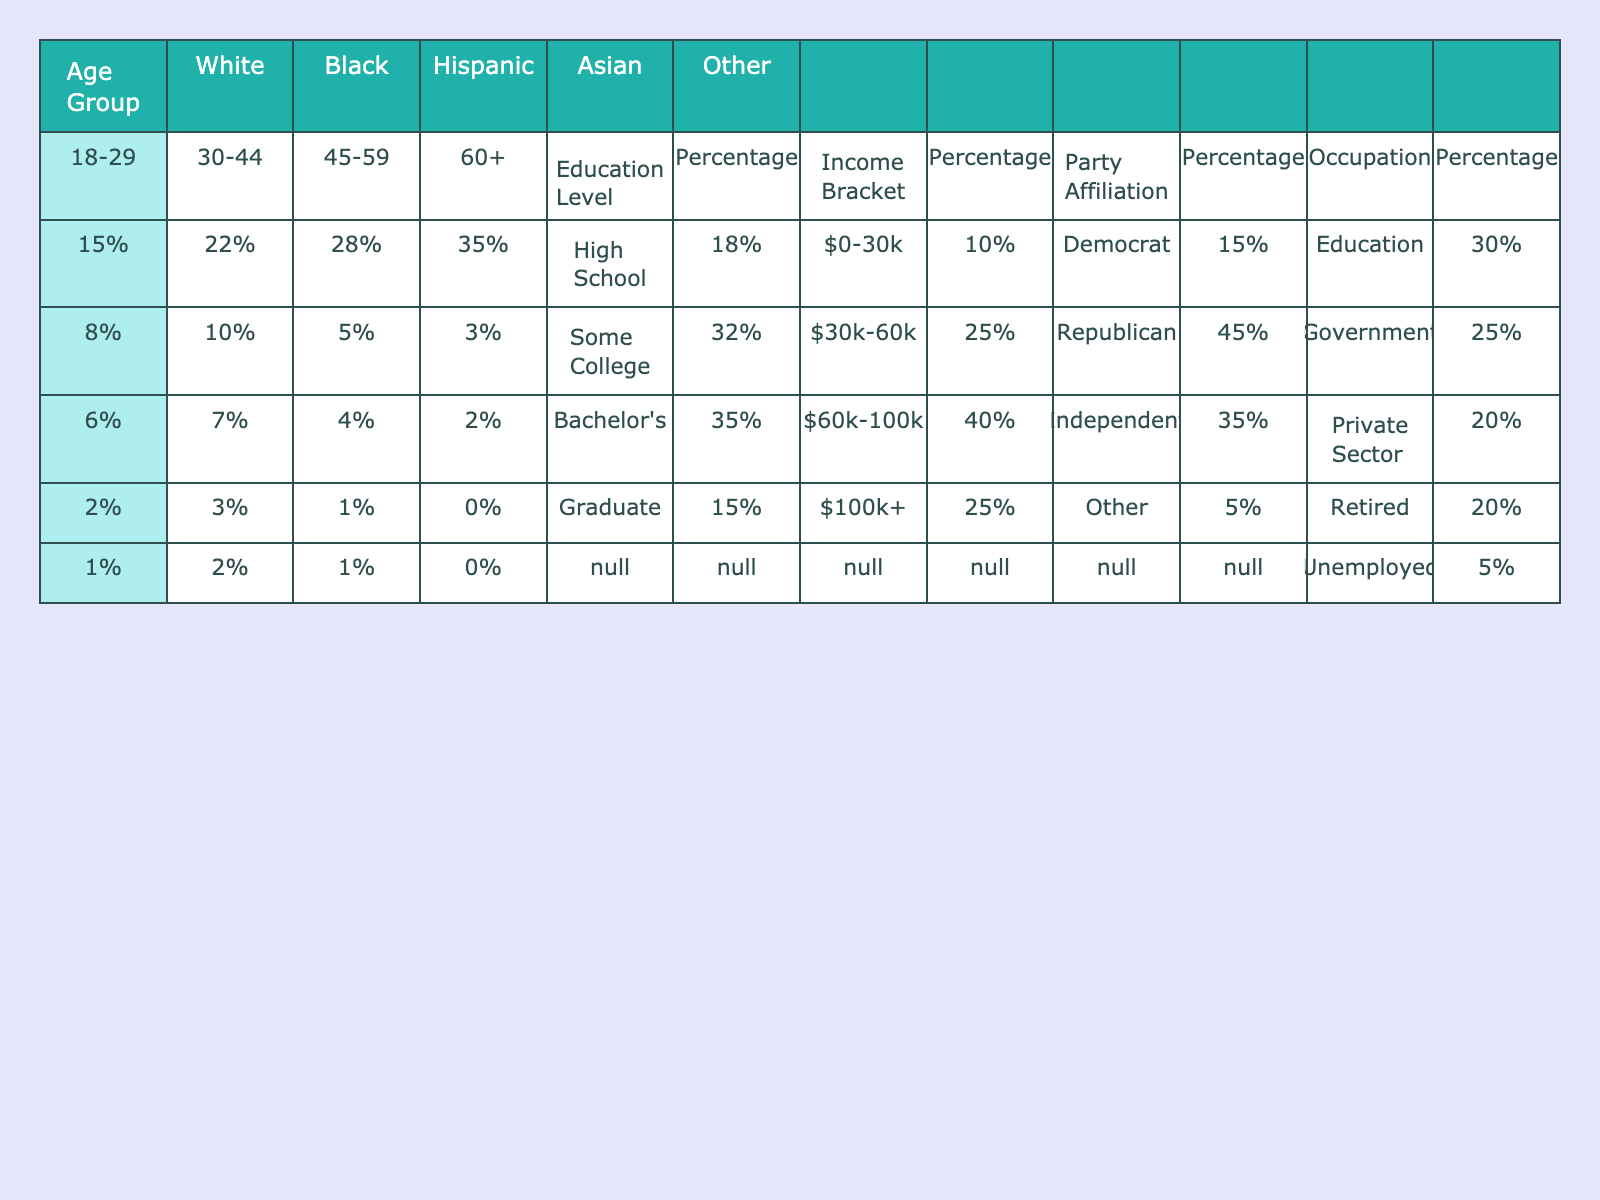What percentage of the history teacher's supporters are aged 18-29? The table shows that 15% of supporters belong to the 18-29 age group.
Answer: 15% What is the percentage of supporters with a Bachelor's degree? The table indicates that 35% of supporters have a Bachelor's degree.
Answer: 35% How many age groups have a higher percentage of White supporters compared to the 45-59 age group? Looking at the age groups, the 18-29 (15%), 30-44 (22%), and 60+ (35%) groups all have higher percentages of White supporters than the 45-59 age group (28%). Therefore, there are three age groups.
Answer: 3 Is the majority of the supporters' income distributed in the $60k-100k bracket? The table shows that 40% of supporters are in the $60k-100k bracket, which is more than any other income bracket, thus this statement is true.
Answer: Yes What is the combined percentage of Black and Hispanic supporters in the 30-44 age group? For the 30-44 age group, the Black supporters are 10% and Hispanic supporters are 7%. Adding these together gives 10% + 7% = 17%.
Answer: 17% What is the difference in percentage points between the highest and lowest education level among the supporters? High School holders are 18% and Graduate holders are 15%. The difference is calculated as 18% - 15% = 3%.
Answer: 3% Which occupation group has the largest percentage of supporters and what is that percentage? The occupation group with the largest percentage is Education, with 30% of supporters.
Answer: 30% If you combine the percentages of Democrat and Independent supporters, what percentage do they represent together? Democrat supporters are 15% and Independent supporters are 35%. Adding these gives 15% + 35% = 50%.
Answer: 50% What percentage of Asian supporters are in the 60+ age group? The table indicates that there are no Asian supporters (0%) in the 60+ age group.
Answer: 0% Based on the table, which demographic group contributes the least percentage of supporters in the 18-29 age bracket? Among the listed demographics, the "Other" category has the least percentage of supporters in the 18-29 age group at 1%.
Answer: 1% 